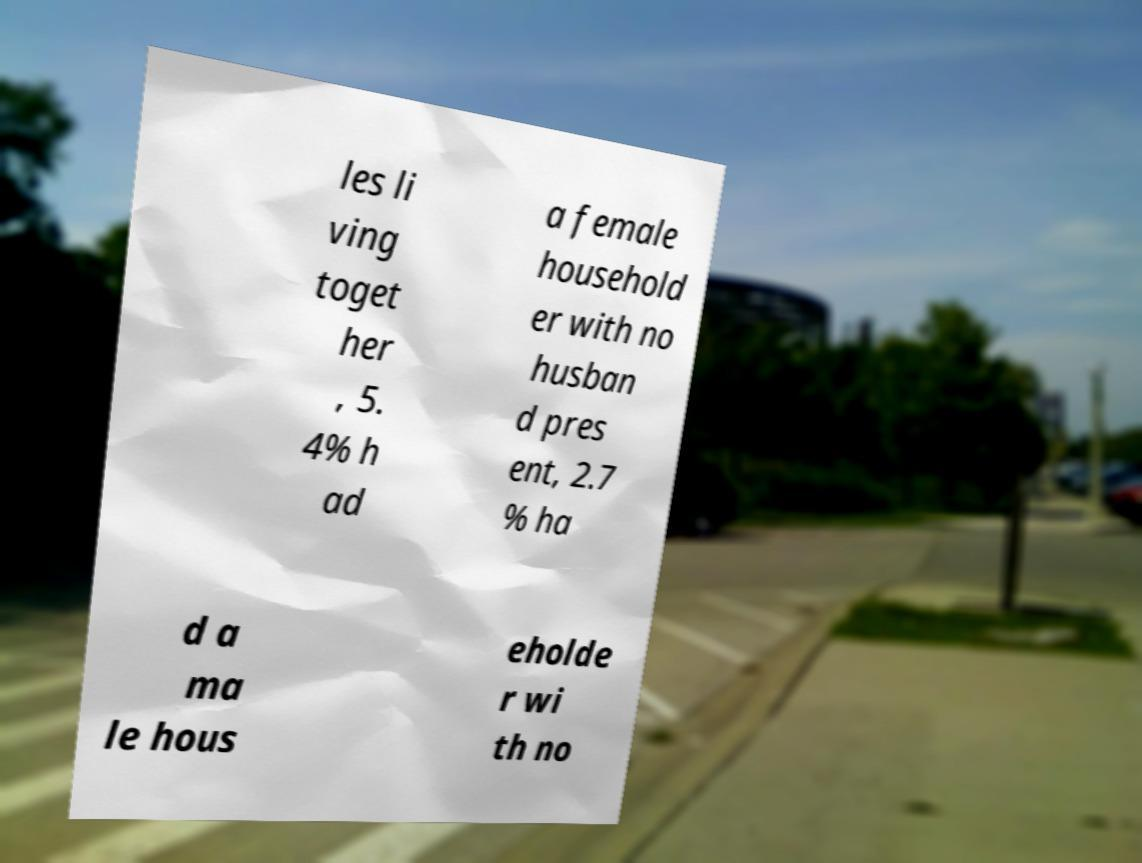Can you read and provide the text displayed in the image?This photo seems to have some interesting text. Can you extract and type it out for me? les li ving toget her , 5. 4% h ad a female household er with no husban d pres ent, 2.7 % ha d a ma le hous eholde r wi th no 